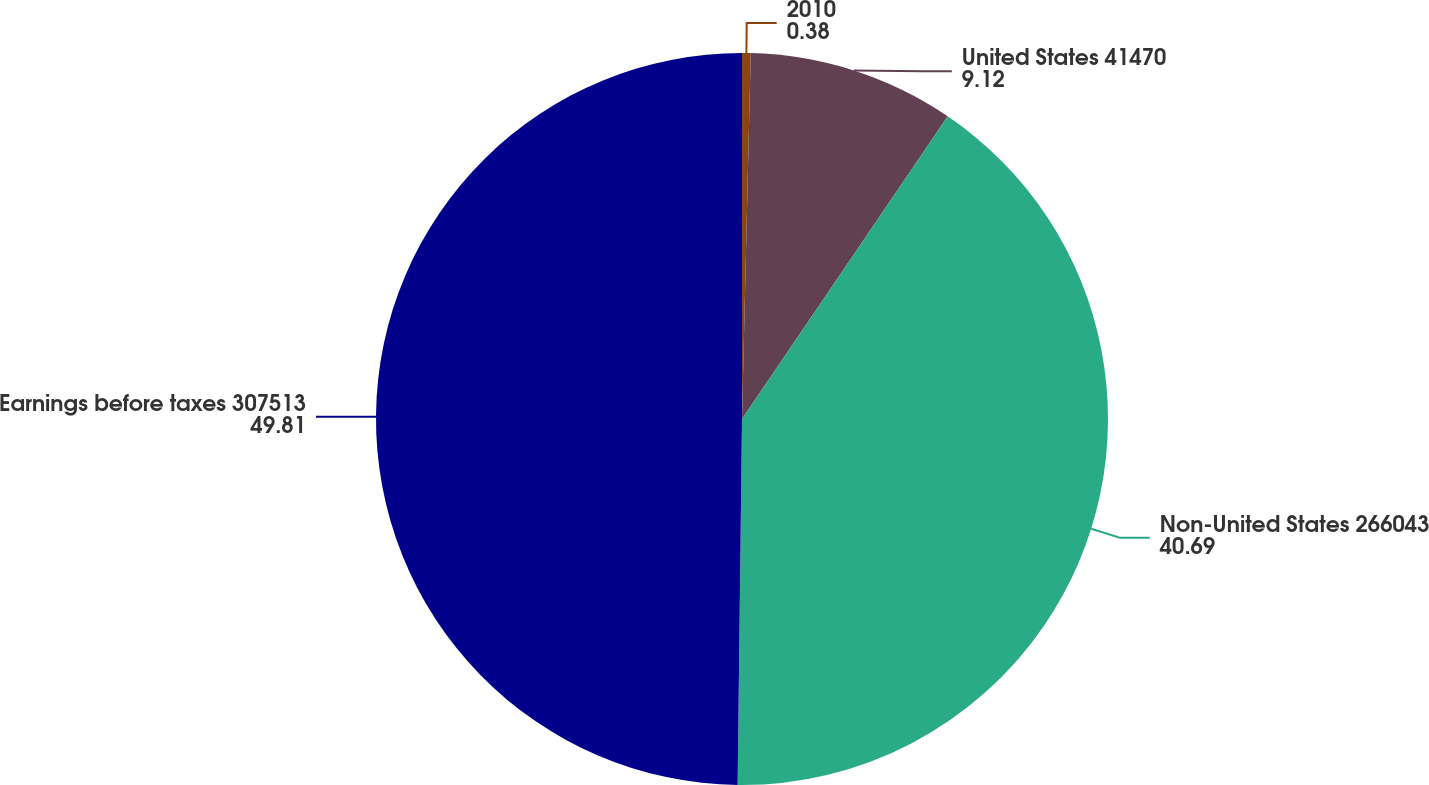<chart> <loc_0><loc_0><loc_500><loc_500><pie_chart><fcel>2010<fcel>United States 41470<fcel>Non-United States 266043<fcel>Earnings before taxes 307513<nl><fcel>0.38%<fcel>9.12%<fcel>40.69%<fcel>49.81%<nl></chart> 